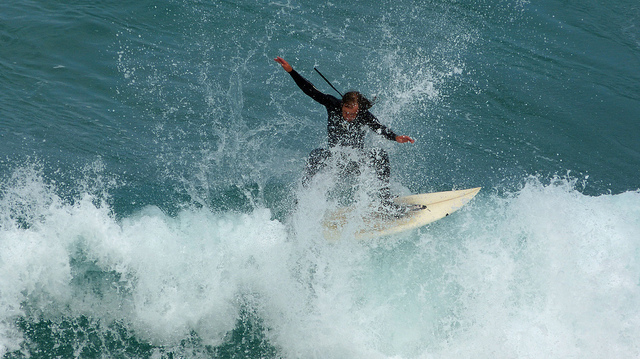<image>Are they surfing on a longboard? I'm not sure if they are surfing on a longboard. The answers are mixed. Are they surfing on a longboard? I am not sure if they are surfing on a longboard. It can be both yes and no. 